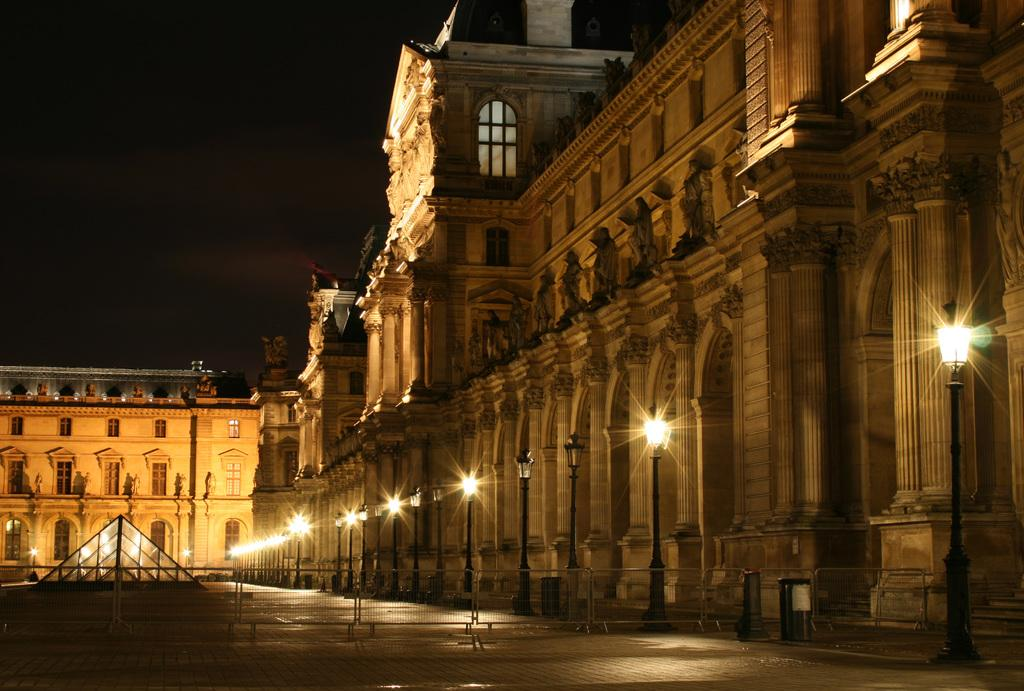What type of structure is visible in the image? There is a building in the image. What artistic elements can be seen in the image? There are sculptures in the image. What are the vertical supports in the image used for? There are poles in the image, which may be used for various purposes such as lighting or signage. What can be seen illuminating the area in the image? There are lights in the image. What might be used to control the flow of people or vehicles in the image? There are barriers in the image. What objects are present for waste disposal in the image? There are dustbins in the image. What type of sound can be heard coming from the chess game in the image? There is no chess game present in the image, so it is not possible to determine what, if any, sounds might be heard. 